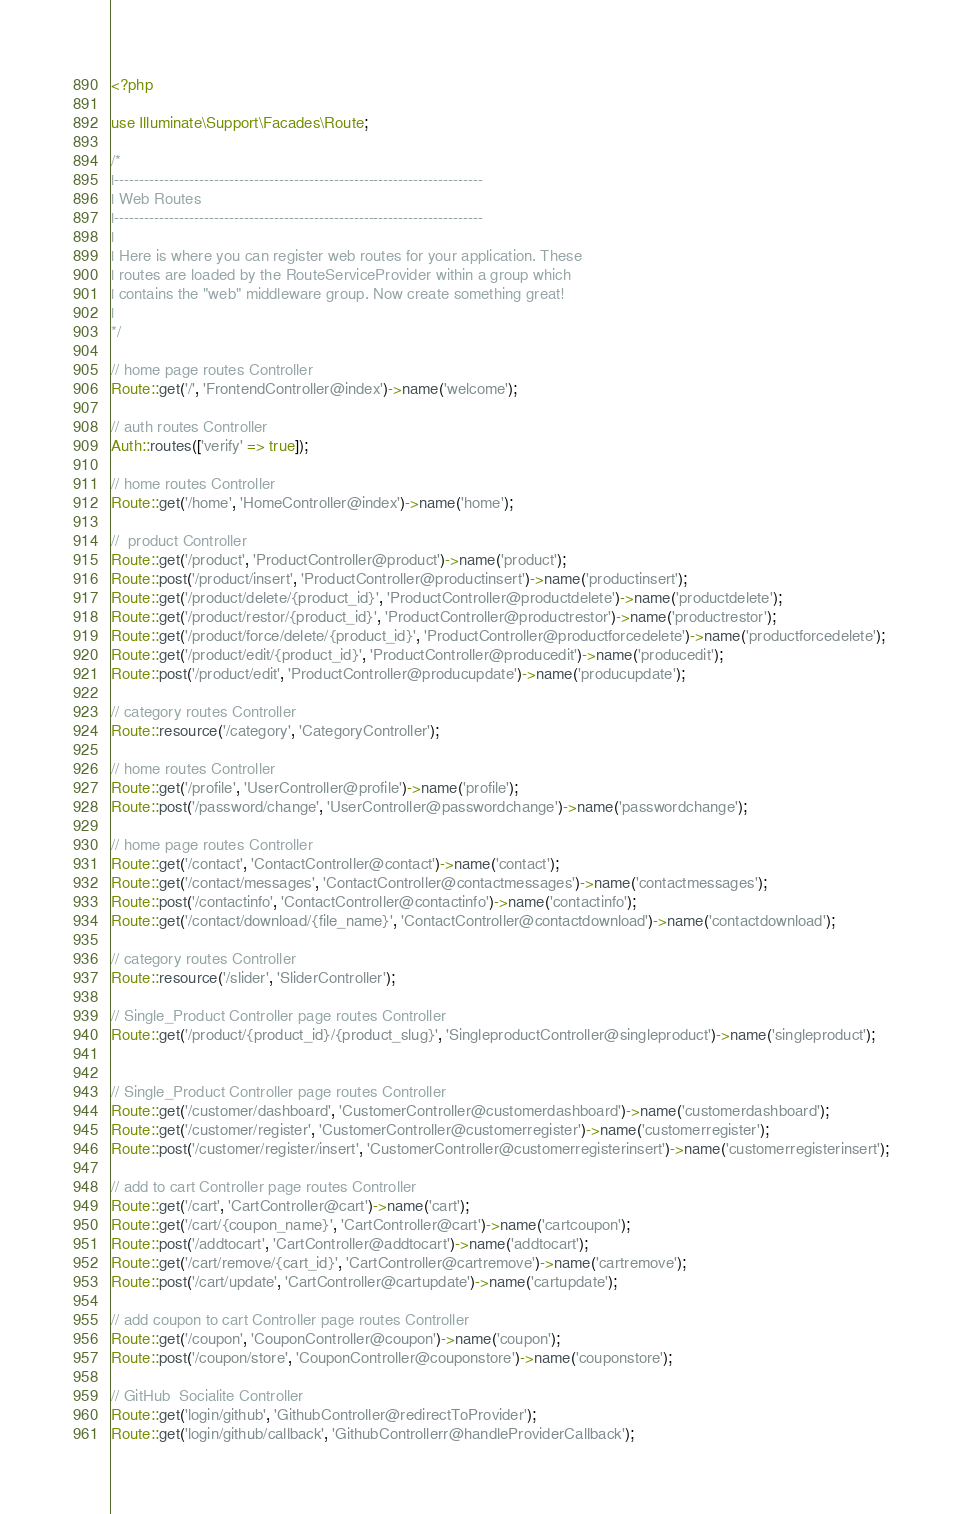Convert code to text. <code><loc_0><loc_0><loc_500><loc_500><_PHP_><?php

use Illuminate\Support\Facades\Route;

/*
|--------------------------------------------------------------------------
| Web Routes
|--------------------------------------------------------------------------
|
| Here is where you can register web routes for your application. These
| routes are loaded by the RouteServiceProvider within a group which
| contains the "web" middleware group. Now create something great!
|
*/

// home page routes Controller
Route::get('/', 'FrontendController@index')->name('welcome');

// auth routes Controller
Auth::routes(['verify' => true]);

// home routes Controller
Route::get('/home', 'HomeController@index')->name('home');

//  product Controller
Route::get('/product', 'ProductController@product')->name('product');
Route::post('/product/insert', 'ProductController@productinsert')->name('productinsert');
Route::get('/product/delete/{product_id}', 'ProductController@productdelete')->name('productdelete');
Route::get('/product/restor/{product_id}', 'ProductController@productrestor')->name('productrestor');
Route::get('/product/force/delete/{product_id}', 'ProductController@productforcedelete')->name('productforcedelete');
Route::get('/product/edit/{product_id}', 'ProductController@producedit')->name('producedit');
Route::post('/product/edit', 'ProductController@producupdate')->name('producupdate');

// category routes Controller
Route::resource('/category', 'CategoryController');

// home routes Controller
Route::get('/profile', 'UserController@profile')->name('profile');
Route::post('/password/change', 'UserController@passwordchange')->name('passwordchange');

// home page routes Controller
Route::get('/contact', 'ContactController@contact')->name('contact');
Route::get('/contact/messages', 'ContactController@contactmessages')->name('contactmessages');
Route::post('/contactinfo', 'ContactController@contactinfo')->name('contactinfo');
Route::get('/contact/download/{file_name}', 'ContactController@contactdownload')->name('contactdownload');

// category routes Controller
Route::resource('/slider', 'SliderController');

// Single_Product Controller page routes Controller
Route::get('/product/{product_id}/{product_slug}', 'SingleproductController@singleproduct')->name('singleproduct');


// Single_Product Controller page routes Controller
Route::get('/customer/dashboard', 'CustomerController@customerdashboard')->name('customerdashboard');
Route::get('/customer/register', 'CustomerController@customerregister')->name('customerregister');
Route::post('/customer/register/insert', 'CustomerController@customerregisterinsert')->name('customerregisterinsert');

// add to cart Controller page routes Controller
Route::get('/cart', 'CartController@cart')->name('cart');
Route::get('/cart/{coupon_name}', 'CartController@cart')->name('cartcoupon');
Route::post('/addtocart', 'CartController@addtocart')->name('addtocart');
Route::get('/cart/remove/{cart_id}', 'CartController@cartremove')->name('cartremove');
Route::post('/cart/update', 'CartController@cartupdate')->name('cartupdate');

// add coupon to cart Controller page routes Controller
Route::get('/coupon', 'CouponController@coupon')->name('coupon');
Route::post('/coupon/store', 'CouponController@couponstore')->name('couponstore');

// GitHub  Socialite Controller
Route::get('login/github', 'GithubController@redirectToProvider');
Route::get('login/github/callback', 'GithubControllerr@handleProviderCallback');
</code> 